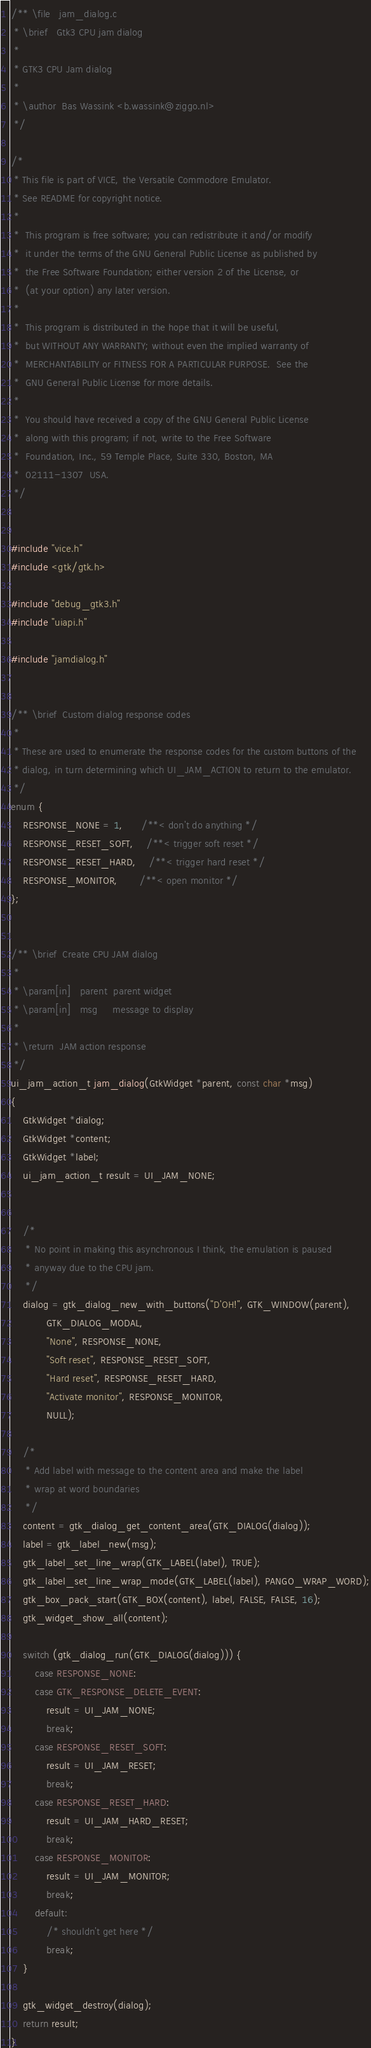<code> <loc_0><loc_0><loc_500><loc_500><_C_>/** \file   jam_dialog.c
 * \brief   Gtk3 CPU jam dialog
 *
 * GTK3 CPU Jam dialog
 *
 * \author  Bas Wassink <b.wassink@ziggo.nl>
 */

/*
 * This file is part of VICE, the Versatile Commodore Emulator.
 * See README for copyright notice.
 *
 *  This program is free software; you can redistribute it and/or modify
 *  it under the terms of the GNU General Public License as published by
 *  the Free Software Foundation; either version 2 of the License, or
 *  (at your option) any later version.
 *
 *  This program is distributed in the hope that it will be useful,
 *  but WITHOUT ANY WARRANTY; without even the implied warranty of
 *  MERCHANTABILITY or FITNESS FOR A PARTICULAR PURPOSE.  See the
 *  GNU General Public License for more details.
 *
 *  You should have received a copy of the GNU General Public License
 *  along with this program; if not, write to the Free Software
 *  Foundation, Inc., 59 Temple Place, Suite 330, Boston, MA
 *  02111-1307  USA.
 */


#include "vice.h"
#include <gtk/gtk.h>

#include "debug_gtk3.h"
#include "uiapi.h"

#include "jamdialog.h"


/** \brief  Custom dialog response codes
 *
 * These are used to enumerate the response codes for the custom buttons of the
 * dialog, in turn determining which UI_JAM_ACTION to return to the emulator.
 */
enum {
    RESPONSE_NONE = 1,      /**< don't do anything */
    RESPONSE_RESET_SOFT,    /**< trigger soft reset */
    RESPONSE_RESET_HARD,    /**< trigger hard reset */
    RESPONSE_MONITOR,       /**< open monitor */
};


/** \brief  Create CPU JAM dialog
 *
 * \param[in]   parent  parent widget
 * \param[in]   msg     message to display
 *
 * \return  JAM action response
 */
ui_jam_action_t jam_dialog(GtkWidget *parent, const char *msg)
{
    GtkWidget *dialog;
    GtkWidget *content;
    GtkWidget *label;
    ui_jam_action_t result = UI_JAM_NONE;


    /*
     * No point in making this asynchronous I think, the emulation is paused
     * anyway due to the CPU jam.
     */
    dialog = gtk_dialog_new_with_buttons("D'OH!", GTK_WINDOW(parent),
            GTK_DIALOG_MODAL,
            "None", RESPONSE_NONE,
            "Soft reset", RESPONSE_RESET_SOFT,
            "Hard reset", RESPONSE_RESET_HARD,
            "Activate monitor", RESPONSE_MONITOR,
            NULL);

    /*
     * Add label with message to the content area and make the label
     * wrap at word boundaries
     */
    content = gtk_dialog_get_content_area(GTK_DIALOG(dialog));
    label = gtk_label_new(msg);
    gtk_label_set_line_wrap(GTK_LABEL(label), TRUE);
    gtk_label_set_line_wrap_mode(GTK_LABEL(label), PANGO_WRAP_WORD);
    gtk_box_pack_start(GTK_BOX(content), label, FALSE, FALSE, 16);
    gtk_widget_show_all(content);

    switch (gtk_dialog_run(GTK_DIALOG(dialog))) {
        case RESPONSE_NONE:
        case GTK_RESPONSE_DELETE_EVENT:
            result = UI_JAM_NONE;
            break;
        case RESPONSE_RESET_SOFT:
            result = UI_JAM_RESET;
            break;
        case RESPONSE_RESET_HARD:
            result = UI_JAM_HARD_RESET;
            break;
        case RESPONSE_MONITOR:
            result = UI_JAM_MONITOR;
            break;
        default:
            /* shouldn't get here */
            break;
    }

    gtk_widget_destroy(dialog);
    return result;
}
</code> 